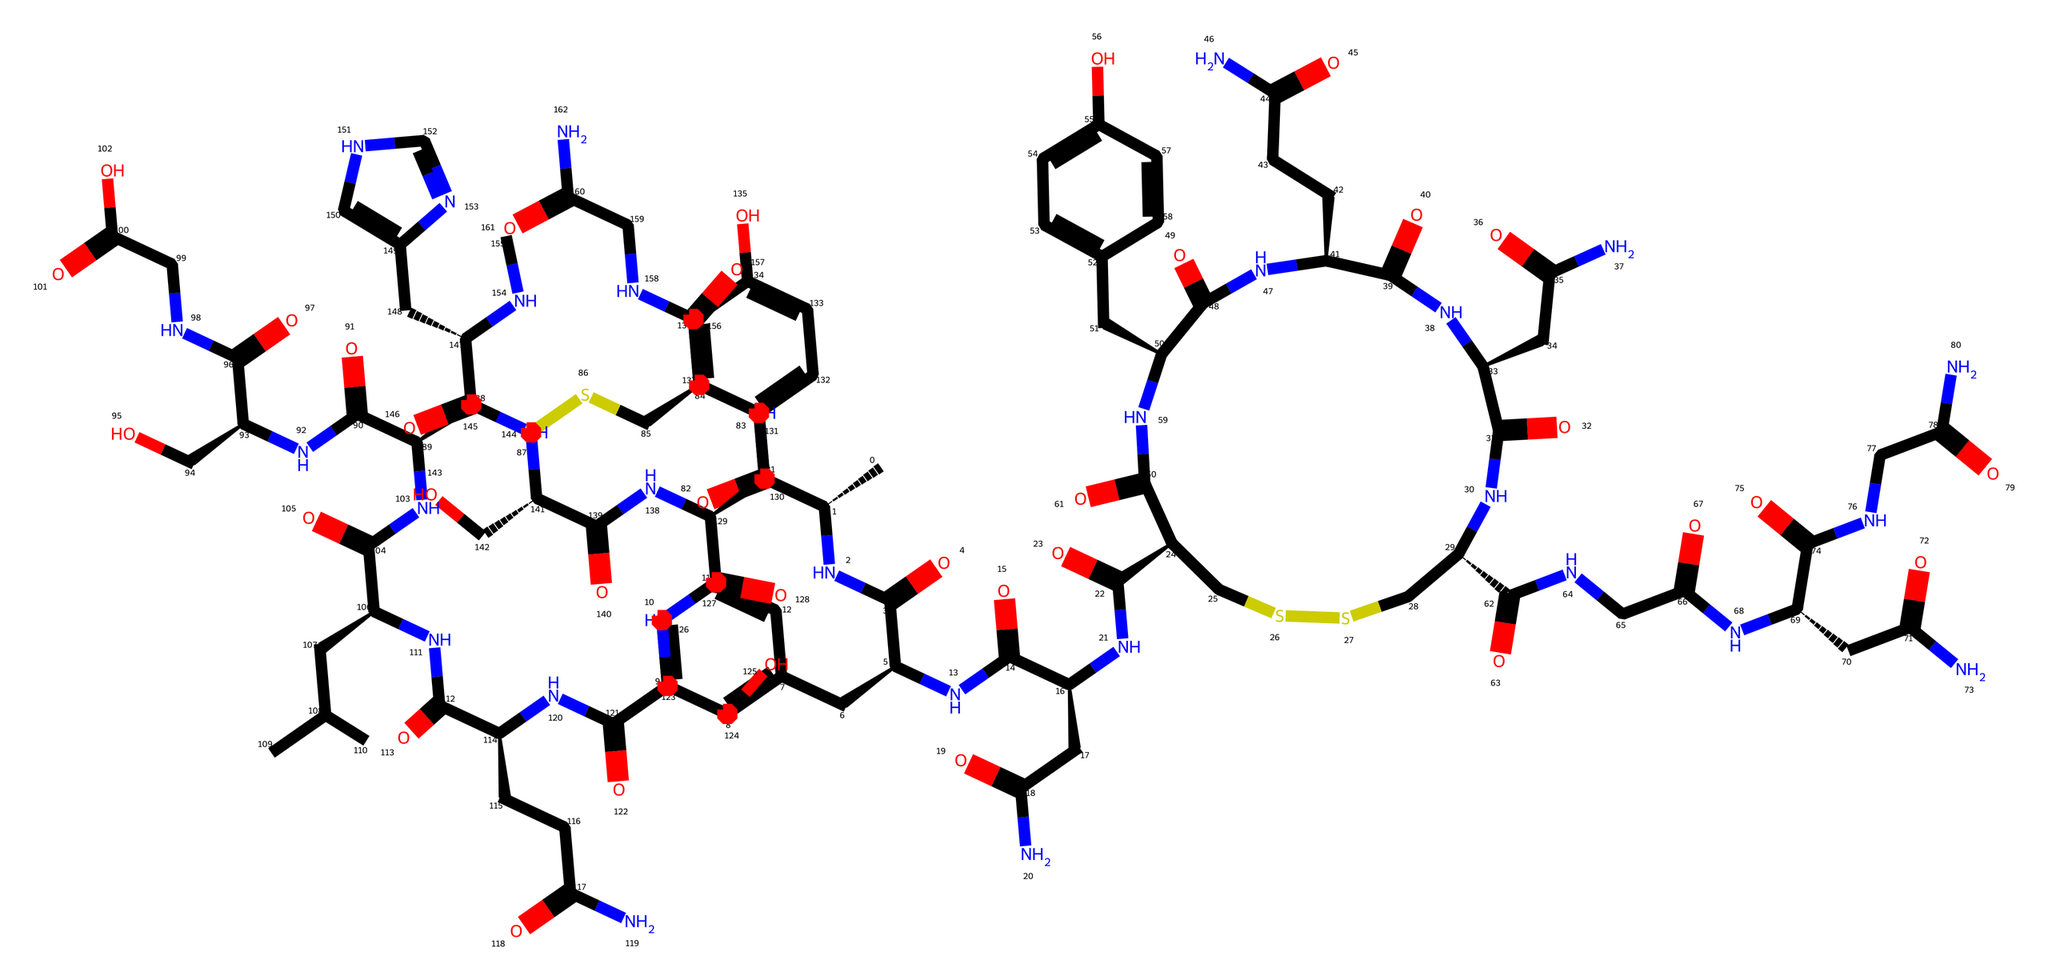What is the molecular formula of oxytocin? To determine the molecular formula, you count the number of each type of atom in the chemical structure based on the SMILES representation. In this case, the structure consists of carbon (C), hydrogen (H), nitrogen (N), and oxygen (O). The molecular formula calculated is C43H66N12O12S2.
Answer: C43H66N12O12S2 How many nitrogen atoms are present in oxytocin? In the given SMILES representation, each occurrence of 'N' represents a nitrogen atom. Counting them reveals there are 12 nitrogen atoms in total in the structure.
Answer: 12 What type of bond connects the atoms in oxytocin? In organic molecules like oxytocin, atoms are primarily held together by covalent bonds. These bonds form due to the sharing of electrons between atoms, particularly with carbon, hydrogen, oxygen, and nitrogen present in the structure.
Answer: covalent bonds Which functional groups are present in oxytocin? Examining the structure reveals the presence of amide (-C(=O)N-) and disulfide (S-S) functional groups. These functional groups are significant in the structure, affecting properties and functions of the hormone.
Answer: amide, disulfide How many rings are present in the structure of oxytocin? Evaluating the structure visually or logically from the SMILES indicates the chemical has two distinct cyclization points that form rings. These contribute to the molecule's stability and biological function.
Answer: 2 What is the significance of disulfide bonds in oxytocin's structure? Disulfide bonds are essential for stabilizing the three-dimensional structure of proteins, including oxytocin. The presence of disulfide linkages between cysteine residues helps maintain the hormone's functional conformation.
Answer: structural stability What is the primary biological function of oxytocin? Oxytocin is primarily known for its role in social bonding, reproduction, and childbirth. It is often referred to as the "bonding hormone" due to its involvement in promoting trust and emotional connections.
Answer: bonding hormone 